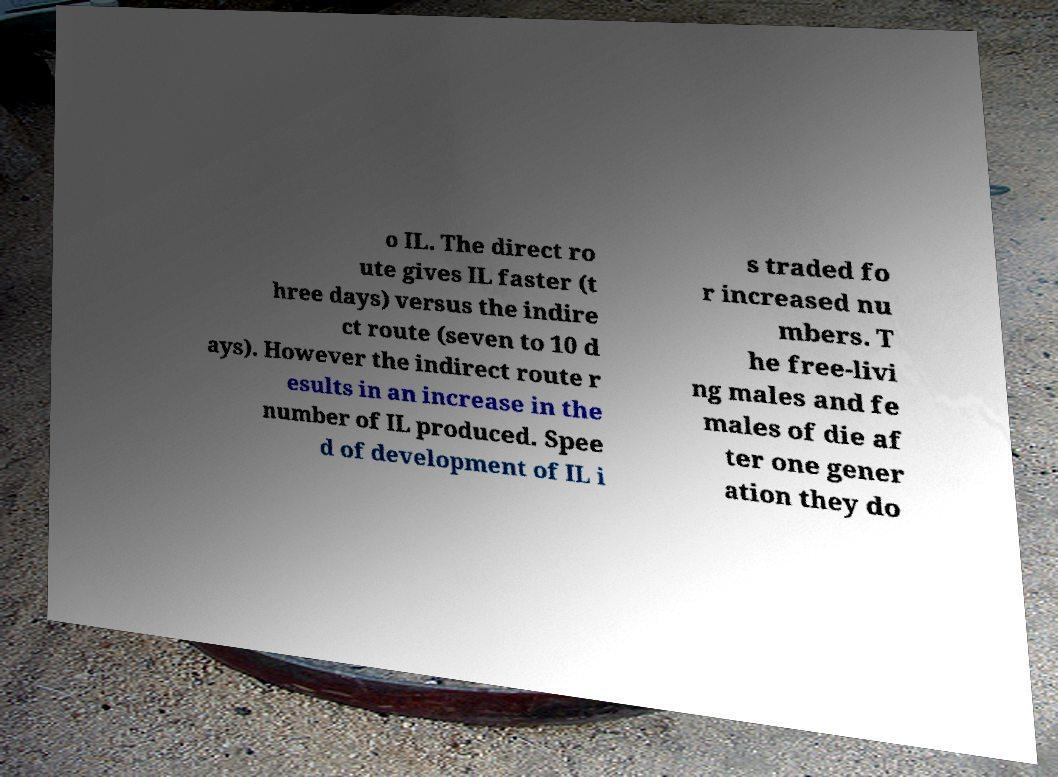Can you read and provide the text displayed in the image?This photo seems to have some interesting text. Can you extract and type it out for me? o IL. The direct ro ute gives IL faster (t hree days) versus the indire ct route (seven to 10 d ays). However the indirect route r esults in an increase in the number of IL produced. Spee d of development of IL i s traded fo r increased nu mbers. T he free-livi ng males and fe males of die af ter one gener ation they do 